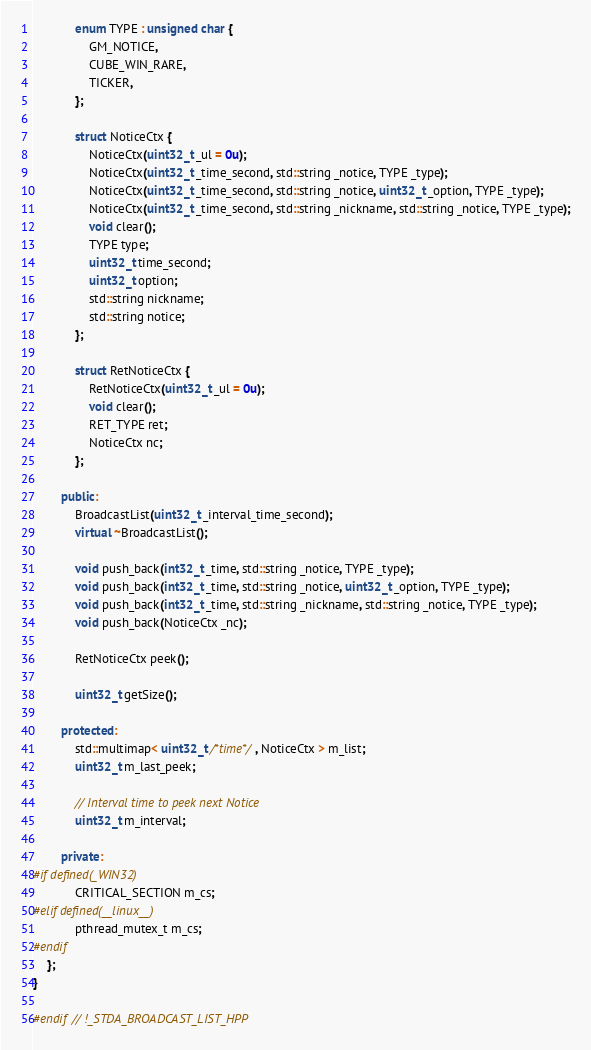Convert code to text. <code><loc_0><loc_0><loc_500><loc_500><_C++_>
			enum TYPE : unsigned char {
				GM_NOTICE,
				CUBE_WIN_RARE,
				TICKER,
			};

			struct NoticeCtx {
				NoticeCtx(uint32_t _ul = 0u);
				NoticeCtx(uint32_t _time_second, std::string _notice, TYPE _type);
				NoticeCtx(uint32_t _time_second, std::string _notice, uint32_t _option, TYPE _type);
				NoticeCtx(uint32_t _time_second, std::string _nickname, std::string _notice, TYPE _type);
				void clear();
				TYPE type;
				uint32_t time_second;
				uint32_t option;
				std::string nickname;
				std::string notice;
			};

			struct RetNoticeCtx {
				RetNoticeCtx(uint32_t _ul = 0u);
				void clear();
				RET_TYPE ret;
				NoticeCtx nc;
			};

		public:
			BroadcastList(uint32_t _interval_time_second);
			virtual ~BroadcastList();

			void push_back(int32_t _time, std::string _notice, TYPE _type);
			void push_back(int32_t _time, std::string _notice, uint32_t _option, TYPE _type);
			void push_back(int32_t _time, std::string _nickname, std::string _notice, TYPE _type);
			void push_back(NoticeCtx _nc);

			RetNoticeCtx peek();

			uint32_t getSize();

		protected:
			std::multimap< uint32_t /*time*/, NoticeCtx > m_list;
			uint32_t m_last_peek;

			// Interval time to peek next Notice
			uint32_t m_interval;

		private:
#if defined(_WIN32)
			CRITICAL_SECTION m_cs;
#elif defined(__linux__)
			pthread_mutex_t m_cs;
#endif
	};
}

#endif // !_STDA_BROADCAST_LIST_HPP
</code> 